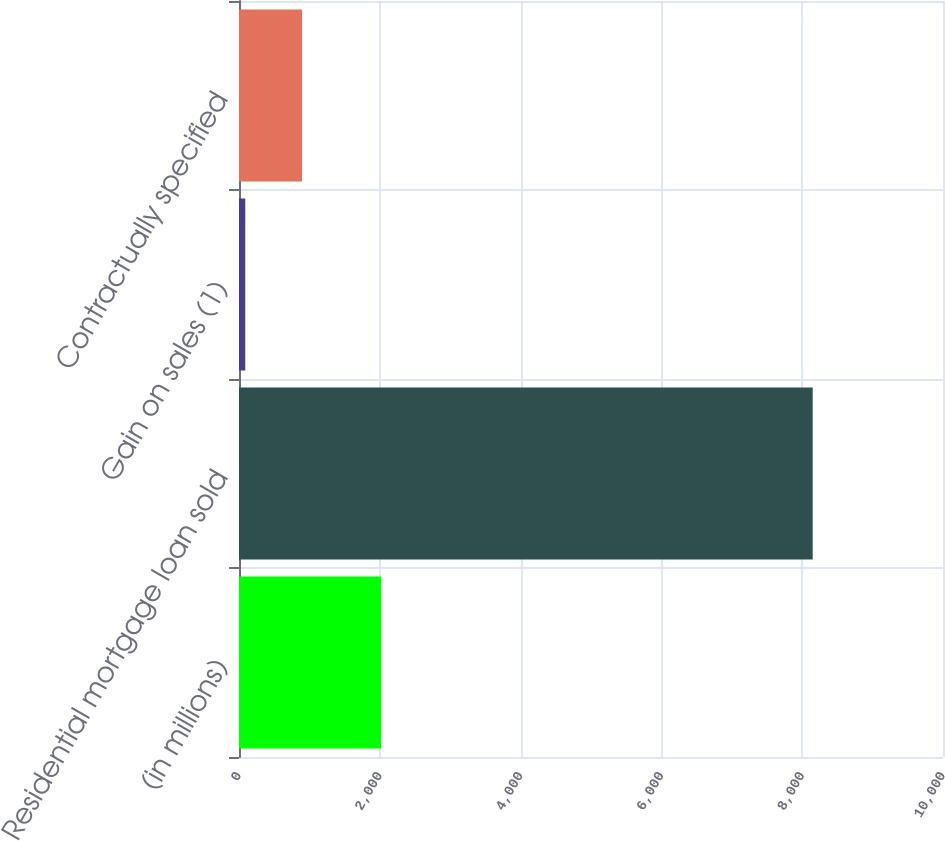<chart> <loc_0><loc_0><loc_500><loc_500><bar_chart><fcel>(in millions)<fcel>Residential mortgage loan sold<fcel>Gain on sales (1)<fcel>Contractually specified<nl><fcel>2018<fcel>8149<fcel>89<fcel>895<nl></chart> 